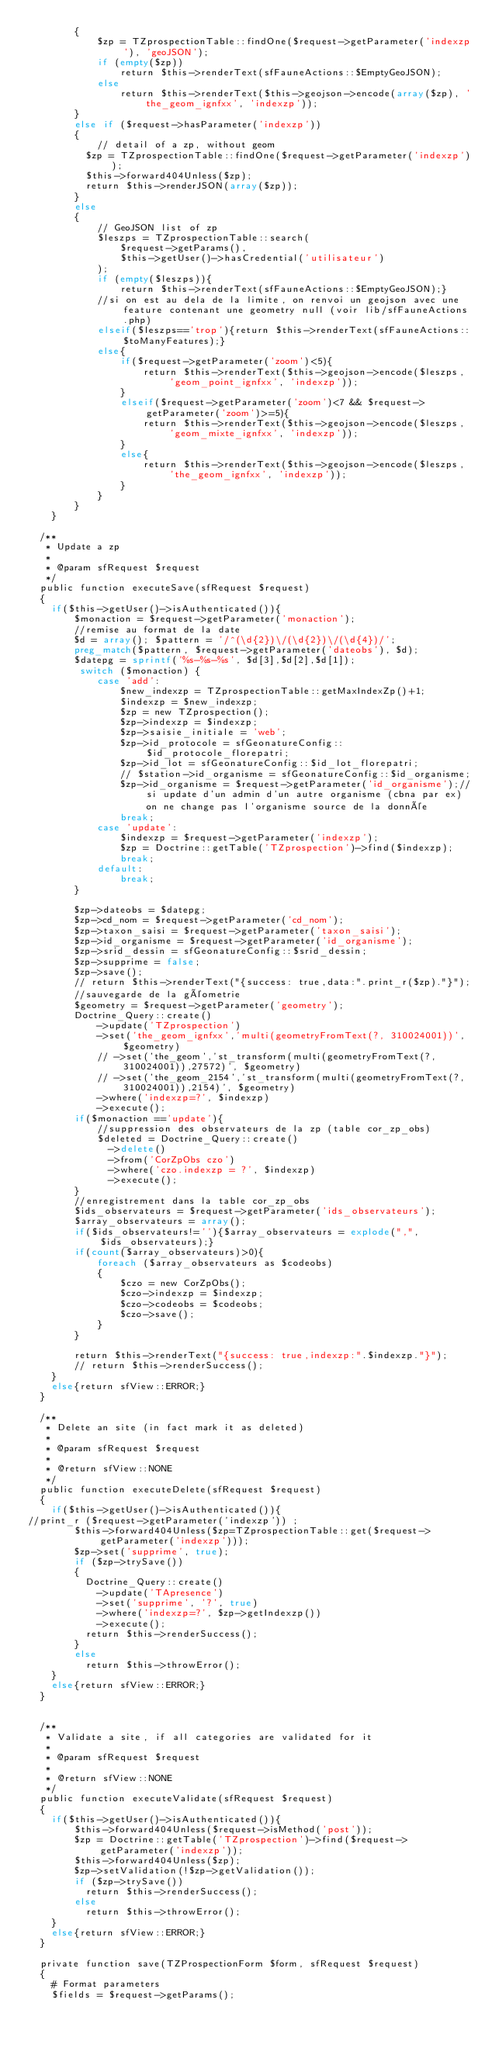<code> <loc_0><loc_0><loc_500><loc_500><_PHP_>        {
            $zp = TZprospectionTable::findOne($request->getParameter('indexzp'), 'geoJSON');
            if (empty($zp))
                return $this->renderText(sfFauneActions::$EmptyGeoJSON);
            else
                return $this->renderText($this->geojson->encode(array($zp), 'the_geom_ignfxx', 'indexzp'));
        }
        else if ($request->hasParameter('indexzp'))
        {
            // detail of a zp, without geom
          $zp = TZprospectionTable::findOne($request->getParameter('indexzp'));
          $this->forward404Unless($zp);
          return $this->renderJSON(array($zp));
        }
        else
        {
            // GeoJSON list of zp
            $leszps = TZprospectionTable::search(
                $request->getParams(), 
                $this->getUser()->hasCredential('utilisateur')
            );
            if (empty($leszps)){
                return $this->renderText(sfFauneActions::$EmptyGeoJSON);}
            //si on est au dela de la limite, on renvoi un geojson avec une feature contenant une geometry null (voir lib/sfFauneActions.php)
            elseif($leszps=='trop'){return $this->renderText(sfFauneActions::$toManyFeatures);}
            else{
                if($request->getParameter('zoom')<5){
                    return $this->renderText($this->geojson->encode($leszps, 'geom_point_ignfxx', 'indexzp'));
                }
                elseif($request->getParameter('zoom')<7 && $request->getParameter('zoom')>=5){
                    return $this->renderText($this->geojson->encode($leszps, 'geom_mixte_ignfxx', 'indexzp'));
                }
                else{
                    return $this->renderText($this->geojson->encode($leszps, 'the_geom_ignfxx', 'indexzp')); 
                }
            }
        }
    }
	
  /**
   * Update a zp
   *
   * @param sfRequest $request
   */
  public function executeSave(sfRequest $request)
  {
  	if($this->getUser()->isAuthenticated()){
        $monaction = $request->getParameter('monaction');
        //remise au format de la date
        $d = array(); $pattern = '/^(\d{2})\/(\d{2})\/(\d{4})/';
        preg_match($pattern, $request->getParameter('dateobs'), $d);
        $datepg = sprintf('%s-%s-%s', $d[3],$d[2],$d[1]);        
         switch ($monaction) {
            case 'add':
                $new_indexzp = TZprospectionTable::getMaxIndexZp()+1;
                $indexzp = $new_indexzp;
                $zp = new TZprospection();
                $zp->indexzp = $indexzp;
                $zp->saisie_initiale = 'web';
                $zp->id_protocole = sfGeonatureConfig::$id_protocole_florepatri;
                $zp->id_lot = sfGeonatureConfig::$id_lot_florepatri;
                // $station->id_organisme = sfGeonatureConfig::$id_organisme;
                $zp->id_organisme = $request->getParameter('id_organisme');//si update d'un admin d'un autre organisme (cbna par ex) on ne change pas l'organisme source de la donnée
                break;
            case 'update':
                $indexzp = $request->getParameter('indexzp');
                $zp = Doctrine::getTable('TZprospection')->find($indexzp); 
                break;
            default:
                break;
        }
        
        $zp->dateobs = $datepg;
        $zp->cd_nom = $request->getParameter('cd_nom');
        $zp->taxon_saisi = $request->getParameter('taxon_saisi');
        $zp->id_organisme = $request->getParameter('id_organisme');
        $zp->srid_dessin = sfGeonatureConfig::$srid_dessin;
        $zp->supprime = false;
        $zp->save();
        // return $this->renderText("{success: true,data:".print_r($zp)."}");
        //sauvegarde de la géometrie
        $geometry = $request->getParameter('geometry');
        Doctrine_Query::create()
            ->update('TZprospection')
            ->set('the_geom_ignfxx','multi(geometryFromText(?, 310024001))', $geometry)
            // ->set('the_geom','st_transform(multi(geometryFromText(?, 310024001)),27572)', $geometry)
            // ->set('the_geom_2154','st_transform(multi(geometryFromText(?, 310024001)),2154)', $geometry)
            ->where('indexzp=?', $indexzp)
            ->execute();
        if($monaction =='update'){
            //suppression des observateurs de la zp (table cor_zp_obs)
            $deleted = Doctrine_Query::create()
              ->delete()
              ->from('CorZpObs czo')
              ->where('czo.indexzp = ?', $indexzp)
              ->execute();
        }
        //enregistrement dans la table cor_zp_obs
        $ids_observateurs = $request->getParameter('ids_observateurs');
        $array_observateurs = array();
        if($ids_observateurs!=''){$array_observateurs = explode(",",$ids_observateurs);}
        if(count($array_observateurs)>0){
            foreach ($array_observateurs as $codeobs)
            {
                $czo = new CorZpObs();
                $czo->indexzp = $indexzp;
                $czo->codeobs = $codeobs; 
                $czo->save();
            }
        }
          
        return $this->renderText("{success: true,indexzp:".$indexzp."}");
        // return $this->renderSuccess(); 
    }
    else{return sfView::ERROR;}
  }
  
  /**
   * Delete an site (in fact mark it as deleted)
   *
   * @param sfRequest $request
   * 
   * @return sfView::NONE
   */
  public function executeDelete(sfRequest $request)
  {
    if($this->getUser()->isAuthenticated()){ 
//print_r ($request->getParameter('indexzp')) ;   
        $this->forward404Unless($zp=TZprospectionTable::get($request->getParameter('indexzp')));
        $zp->set('supprime', true);
        if ($zp->trySave())
        {
          Doctrine_Query::create()
            ->update('TApresence')
            ->set('supprime', '?', true)
            ->where('indexzp=?', $zp->getIndexzp())
            ->execute();
          return $this->renderSuccess();
        }
        else
          return $this->throwError();
    }
    else{return sfView::ERROR;}
  }
  
  
  /**
   * Validate a site, if all categories are validated for it
   *
   * @param sfRequest $request
   * 
   * @return sfView::NONE
   */
  public function executeValidate(sfRequest $request)
  {
  	if($this->getUser()->isAuthenticated()){
        $this->forward404Unless($request->isMethod('post'));
        $zp = Doctrine::getTable('TZprospection')->find($request->getParameter('indexzp'));
        $this->forward404Unless($zp);
        $zp->setValidation(!$zp->getValidation());
        if ($zp->trySave())
          return $this->renderSuccess();
        else
          return $this->throwError();
    }
    else{return sfView::ERROR;}
  }
  
  private function save(TZProspectionForm $form, sfRequest $request)
  {
  	# Format parameters
  	$fields = $request->getParams(); </code> 